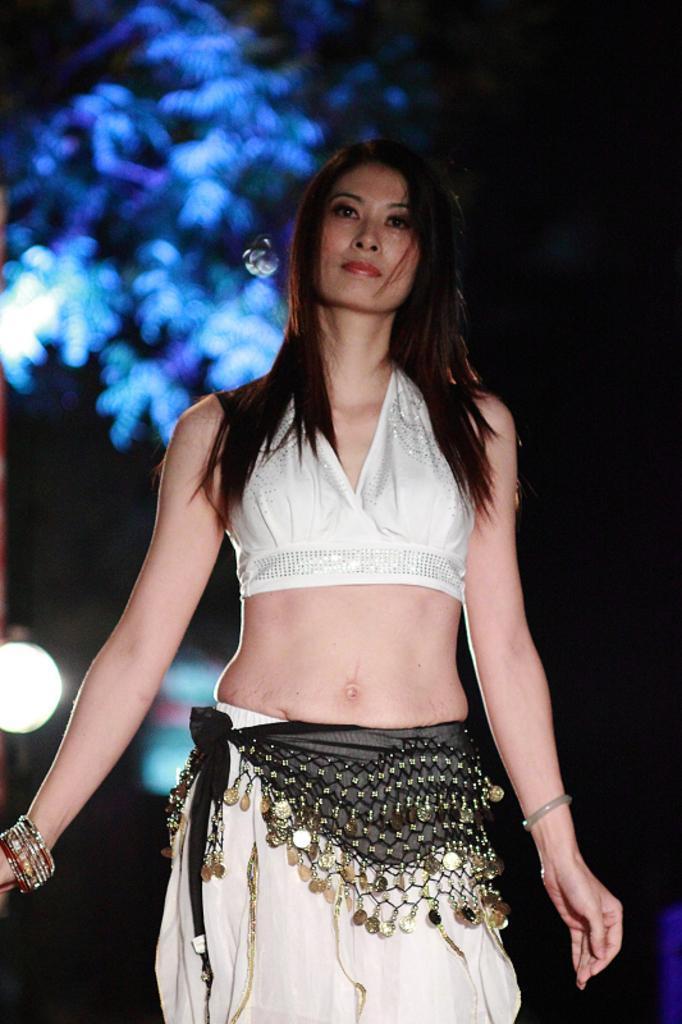Please provide a concise description of this image. In the picture I can see a woman wearing white dress and there is a tree which has blue light on it in the background. 